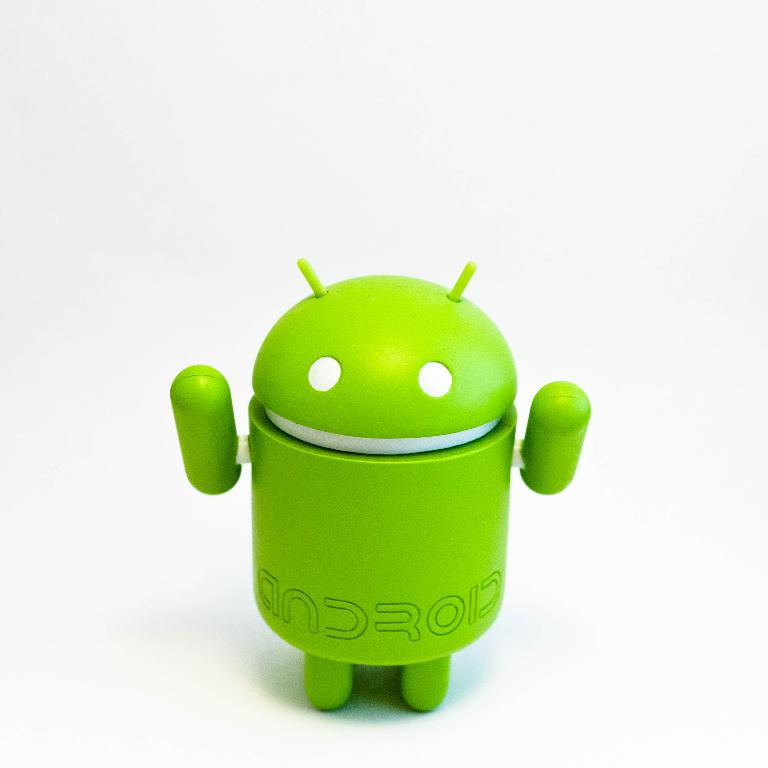How might this Android figure be used in promotional materials? This Android figure could be utilized in promotional materials to convey a sense of fun and innovation, often placed in dynamic and colorful settings to attract tech enthusiasts and consumers looking for user-friendly and cutting-edge technology solutions. Can you suggest any specific scenarios for such promotional use? Certainly! One scenario could involve the Android mascot interacting with various devices, like smartphones and tablets, illustrating its compatibility and versatility. Another idea could be using the figure in an animated sequence where it helps users solve tech-related challenges, showcasing the problem-solving features of Android products. 